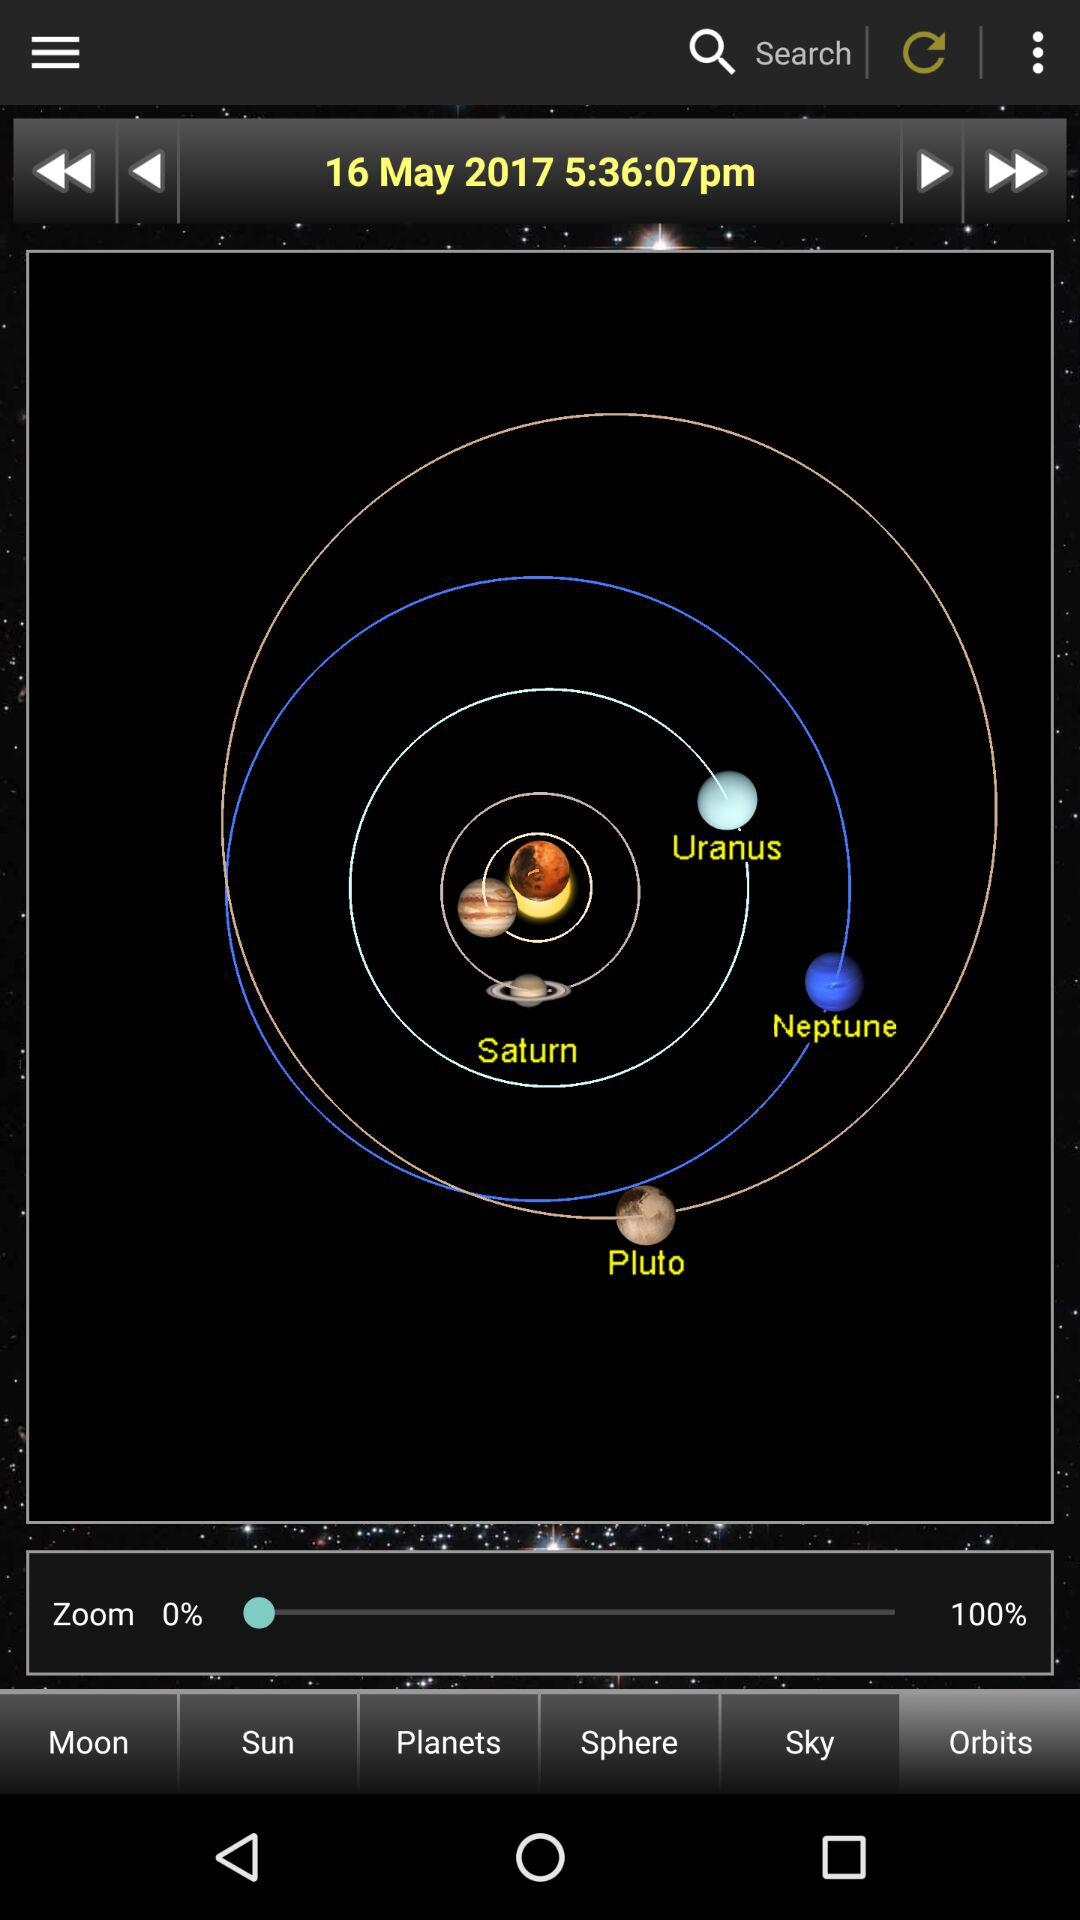What's the date and time? The date is May 16, 2017 and the time is 5:36:07 p.m. 